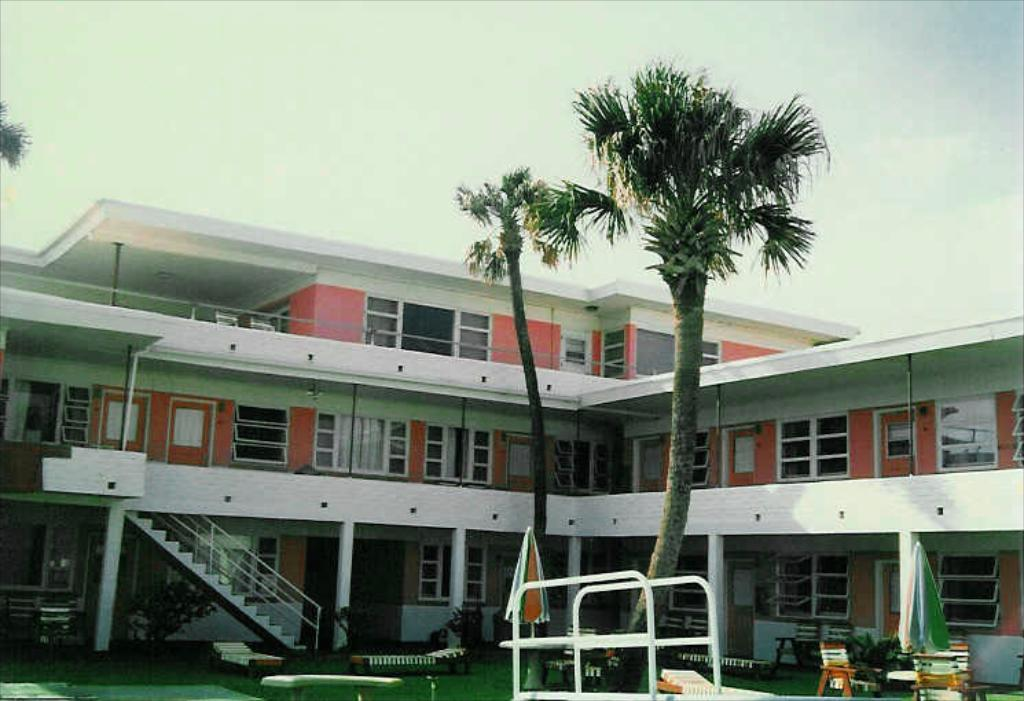What is the main subject of the picture? The main subject of the picture is a building. What specific features can be seen on the building? The building has windows and doors. What can be seen in the background of the picture? There are trees in the background of the picture. What is the condition of the sky in the picture? The sky is clear in the picture. What type of bag is hanging from the horn in the picture? There is no bag or horn present in the image; it features a building with windows and doors, trees in the background, and a clear sky. 